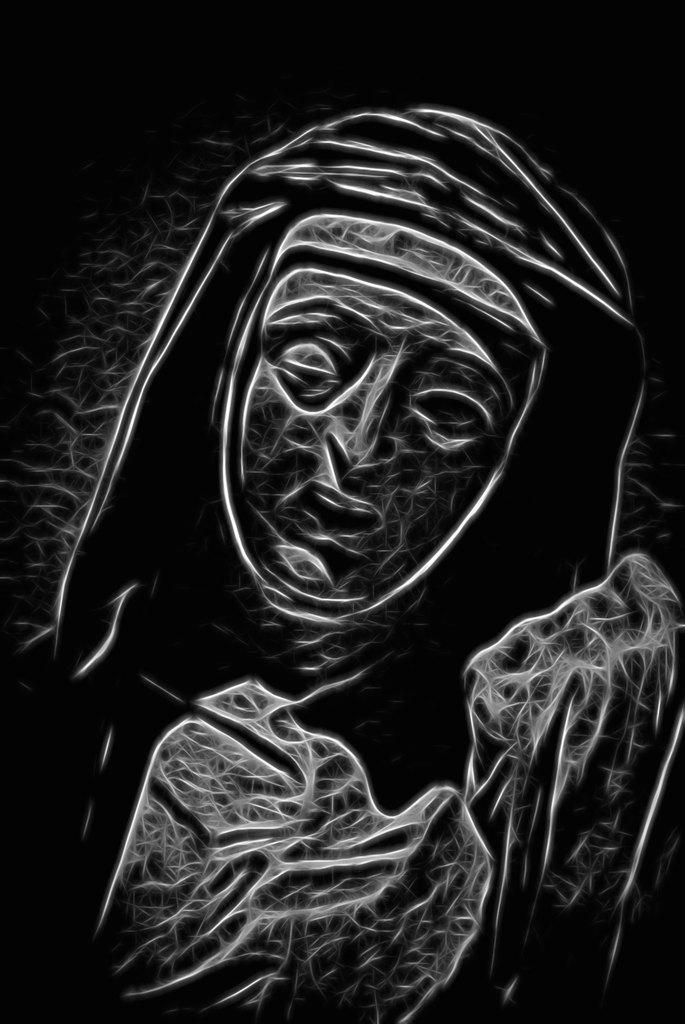What is depicted in the painting in the image? There is a painting of a person in the image. What color is the background of the image? The background of the image is black. How many chairs are visible in the painting? There are no chairs visible in the painting; it only depicts a person. What type of rice is being cooked in the background of the image? There is no rice present in the image; the background is black. 